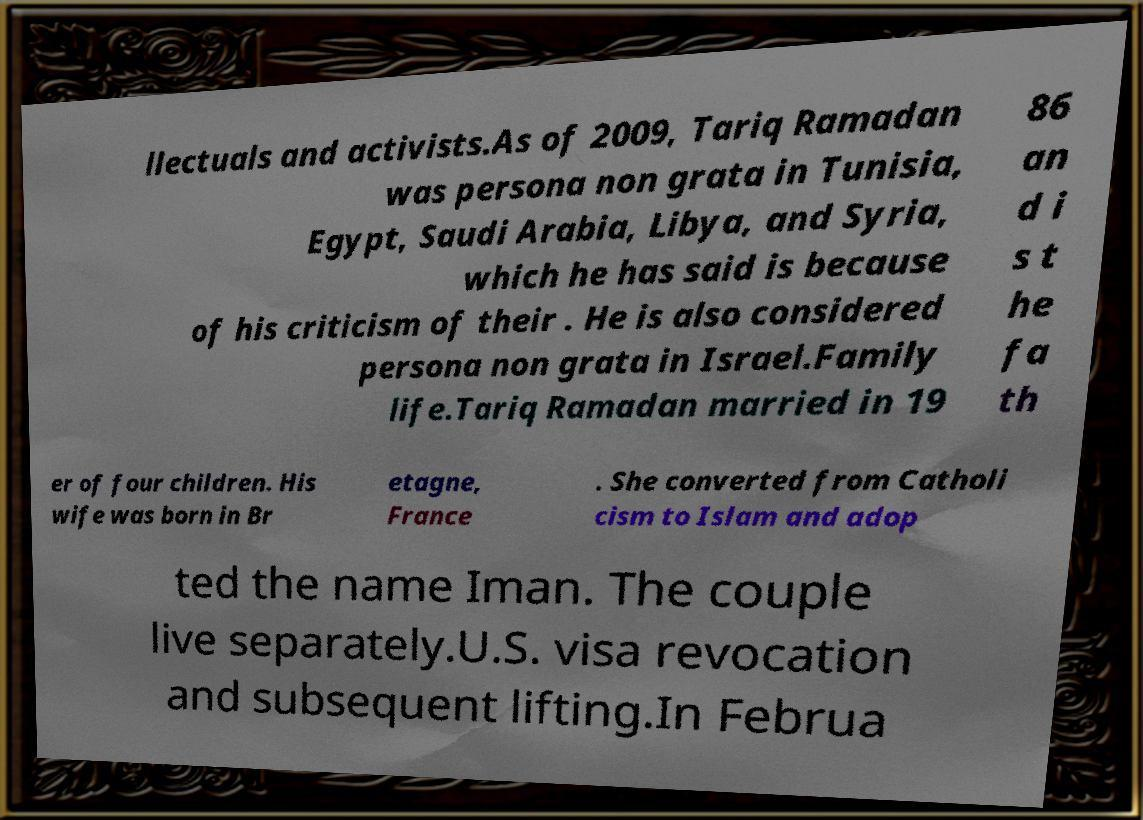Please read and relay the text visible in this image. What does it say? llectuals and activists.As of 2009, Tariq Ramadan was persona non grata in Tunisia, Egypt, Saudi Arabia, Libya, and Syria, which he has said is because of his criticism of their . He is also considered persona non grata in Israel.Family life.Tariq Ramadan married in 19 86 an d i s t he fa th er of four children. His wife was born in Br etagne, France . She converted from Catholi cism to Islam and adop ted the name Iman. The couple live separately.U.S. visa revocation and subsequent lifting.In Februa 